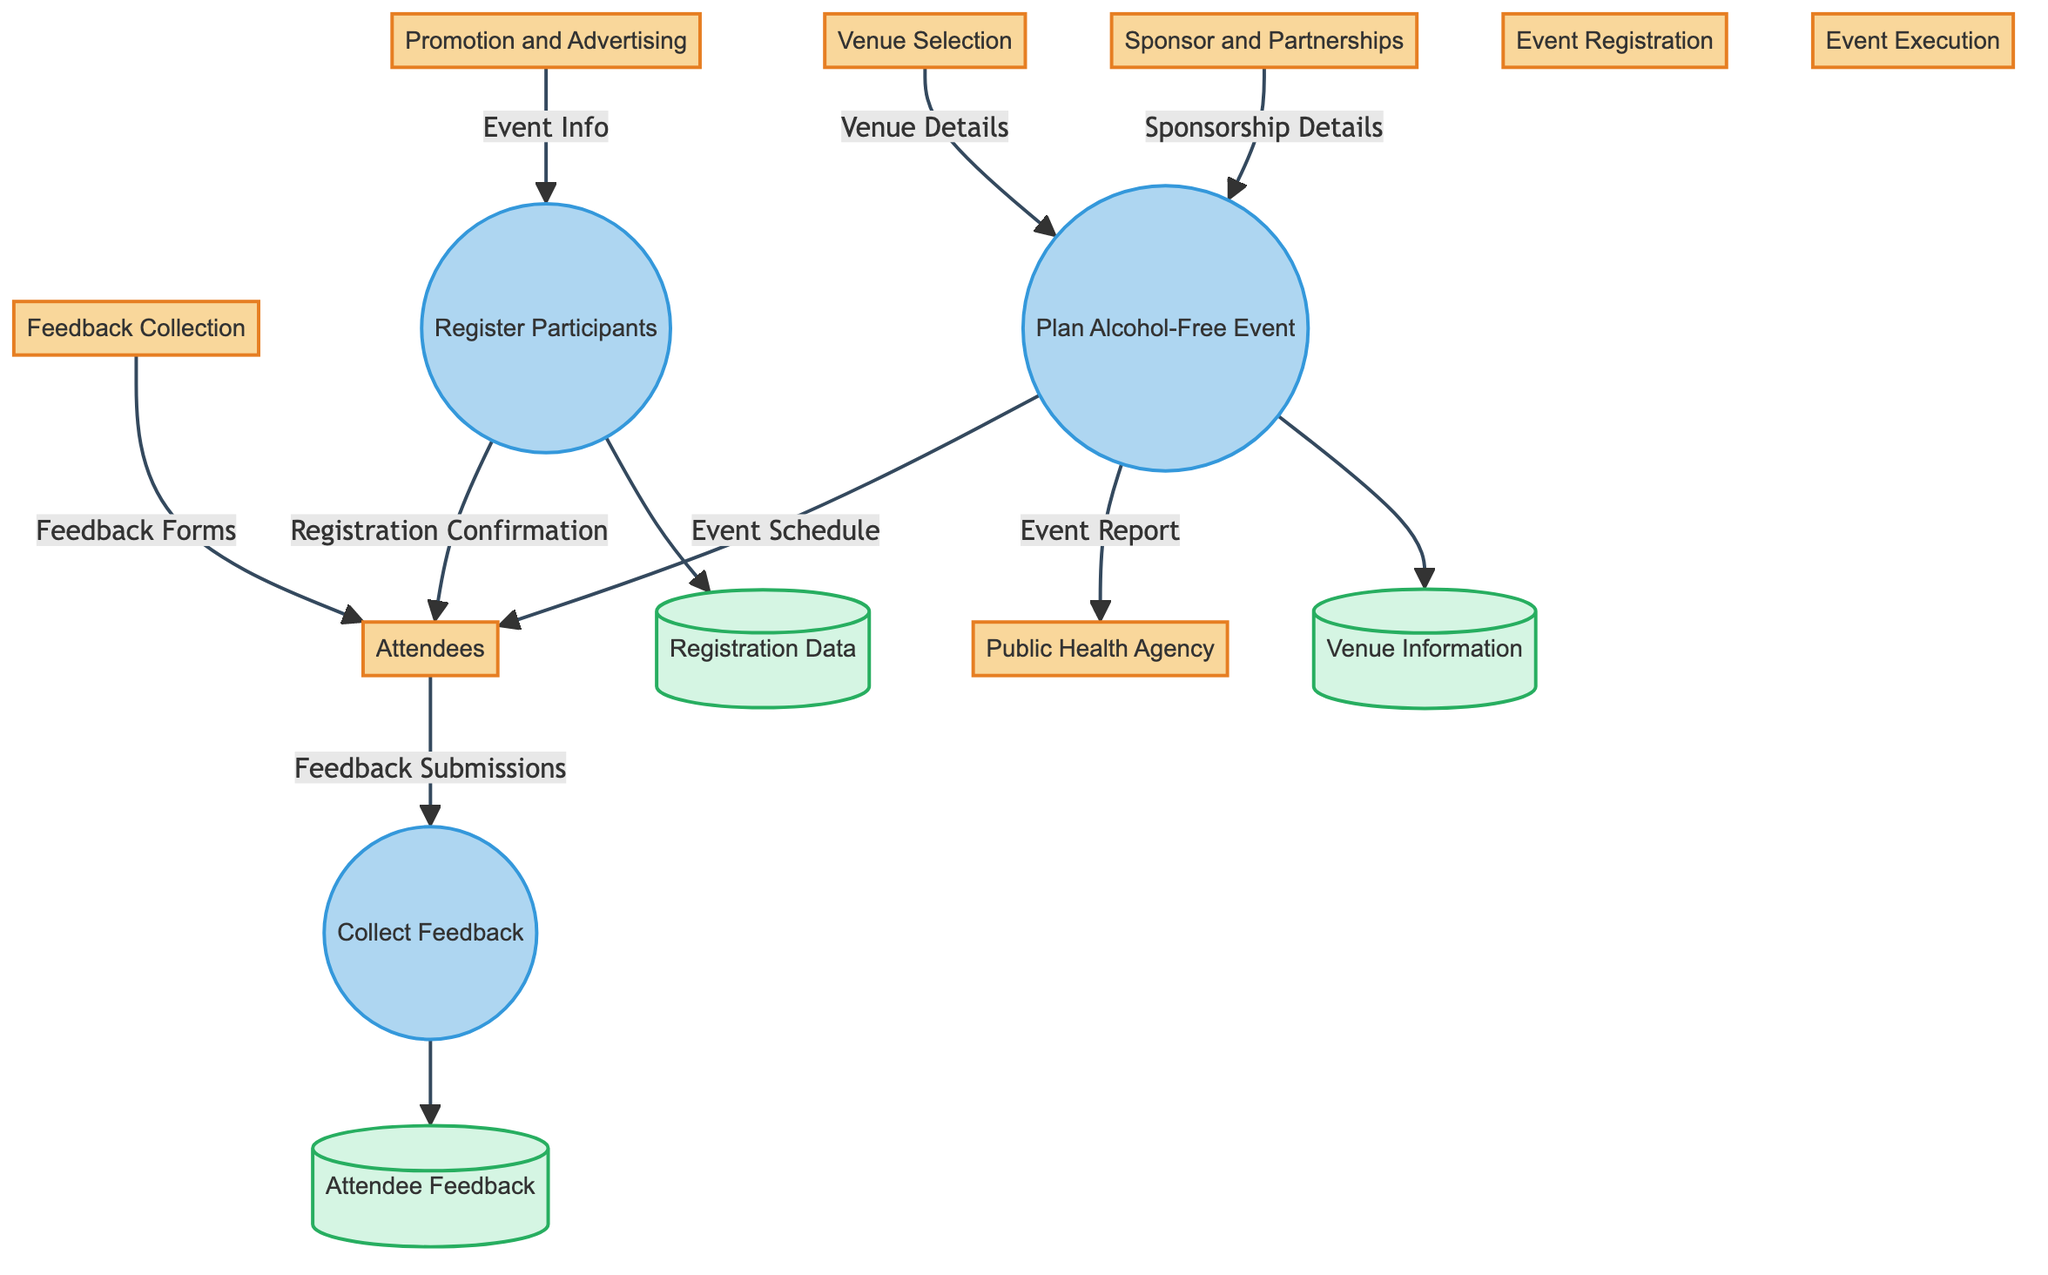What are the entities involved in this process? The diagram outlines several entities including Venue Selection, Promotion and Advertising, Sponsor and Partnerships, Event Registration, Attendees, Event Execution, Feedback Collection, and Public Health Agency.
Answer: Venue Selection, Promotion and Advertising, Sponsor and Partnerships, Event Registration, Attendees, Event Execution, Feedback Collection, Public Health Agency How many processes are represented in the diagram? There are three processes identified in the diagram: Plan Alcohol-Free Event, Register Participants, and Collect Feedback. Counting these gives a total of three processes.
Answer: 3 What data is transferred from Venue Selection to Event Execution? The data flow from Venue Selection to Event Execution is labeled as Venue Details. This establishes a direct relationship between these two entities through this specific data transfer.
Answer: Venue Details Which entity receives Registration Confirmation? The Event Registration process outputs the Registration Confirmation to the Attendees entity. This indicates that the attendees are the recipients of this confirmation.
Answer: Attendees What is the output of the 'Plan Alcohol-Free Event' process? The outputs of the Plan Alcohol-Free Event process are Event Schedule and Event Report. Therefore, both these outputs are directly generated from this process.
Answer: Event Schedule, Event Report What data flows from Feedback Collection to Attendees? Feedback Collection sends Feedback Forms to the Attendees. This establishes the flow of data that connects feedback tools to the participants.
Answer: Feedback Forms What entity is connected to the 'Collect Feedback' process? The 'Collect Feedback' process receives Feedback Forms as input from the Feedback Collection entity. This indicates the link between these two processes concerning feedback management.
Answer: Feedback Collection What data is sent from Event Execution to the Public Health Agency? The Event Execution process communicates an Event Report to the Public Health Agency. This data transfer highlights a key reporting obligation to the public health entity.
Answer: Event Report How many data flows connect the entities? By analyzing the diagram, a total of eight data flows can be identified, depicting how entities and processes are interconnected through data exchanges.
Answer: 8 